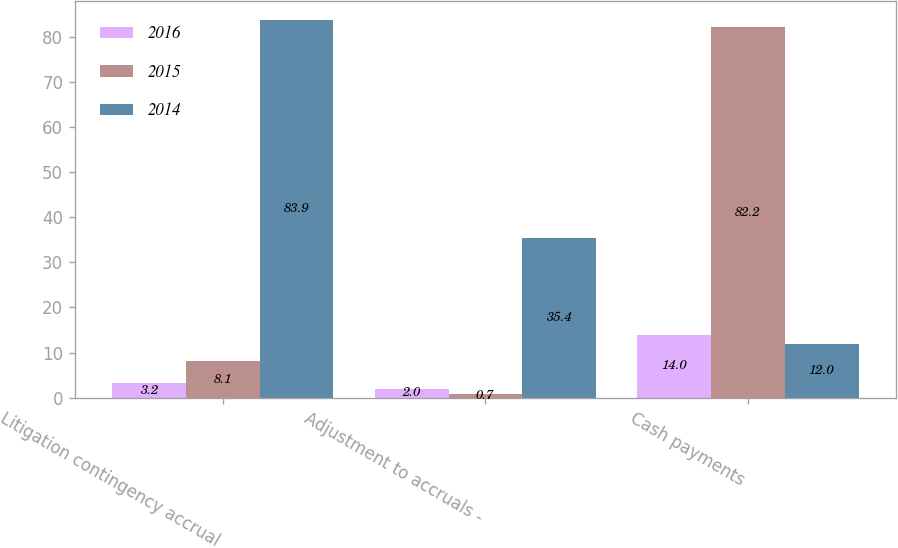Convert chart to OTSL. <chart><loc_0><loc_0><loc_500><loc_500><stacked_bar_chart><ecel><fcel>Litigation contingency accrual<fcel>Adjustment to accruals -<fcel>Cash payments<nl><fcel>2016<fcel>3.2<fcel>2<fcel>14<nl><fcel>2015<fcel>8.1<fcel>0.7<fcel>82.2<nl><fcel>2014<fcel>83.9<fcel>35.4<fcel>12<nl></chart> 